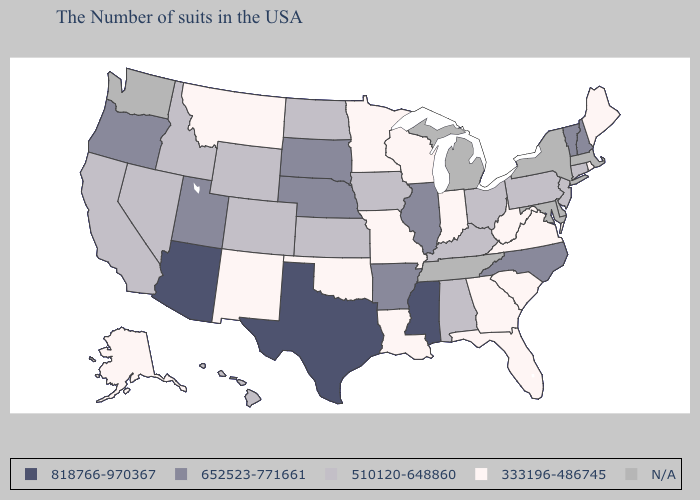Does Arkansas have the lowest value in the USA?
Answer briefly. No. Does New Jersey have the lowest value in the Northeast?
Concise answer only. No. What is the value of Illinois?
Be succinct. 652523-771661. Does Idaho have the highest value in the USA?
Keep it brief. No. Among the states that border Kentucky , does Ohio have the highest value?
Concise answer only. No. What is the lowest value in the USA?
Quick response, please. 333196-486745. What is the value of California?
Quick response, please. 510120-648860. Among the states that border Missouri , does Oklahoma have the lowest value?
Give a very brief answer. Yes. Does the map have missing data?
Concise answer only. Yes. What is the value of Ohio?
Be succinct. 510120-648860. Does Connecticut have the lowest value in the USA?
Give a very brief answer. No. Does Louisiana have the highest value in the South?
Write a very short answer. No. What is the value of California?
Give a very brief answer. 510120-648860. 